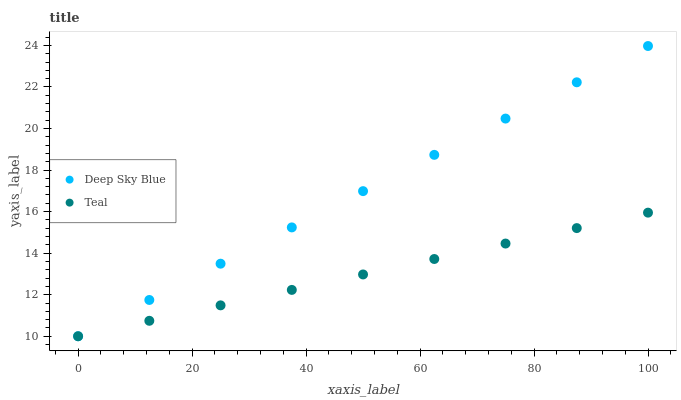Does Teal have the minimum area under the curve?
Answer yes or no. Yes. Does Deep Sky Blue have the maximum area under the curve?
Answer yes or no. Yes. Does Deep Sky Blue have the minimum area under the curve?
Answer yes or no. No. Is Teal the smoothest?
Answer yes or no. Yes. Is Deep Sky Blue the roughest?
Answer yes or no. Yes. Is Deep Sky Blue the smoothest?
Answer yes or no. No. Does Teal have the lowest value?
Answer yes or no. Yes. Does Deep Sky Blue have the highest value?
Answer yes or no. Yes. Does Teal intersect Deep Sky Blue?
Answer yes or no. Yes. Is Teal less than Deep Sky Blue?
Answer yes or no. No. Is Teal greater than Deep Sky Blue?
Answer yes or no. No. 